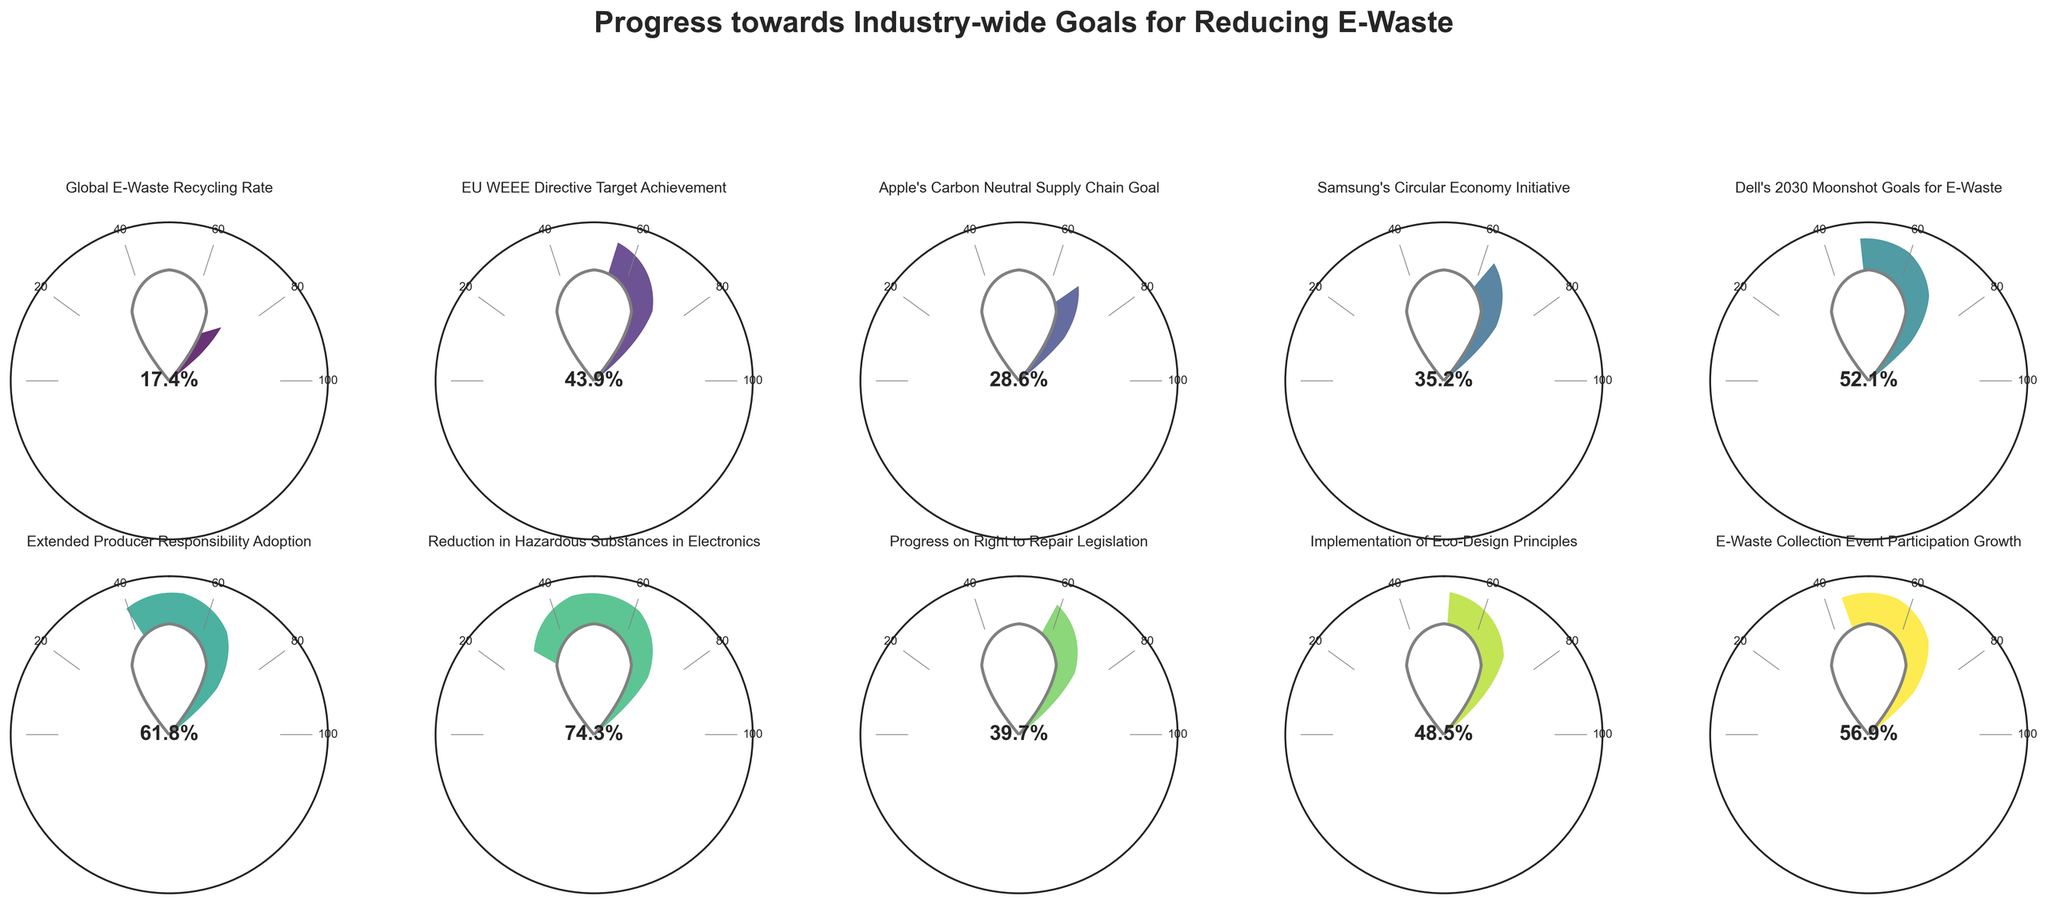Which company has achieved the highest percentage towards their e-waste reduction goals? By observing the gauge charts for each company and comparing the percentages, Dell has the highest percentage of 52.1%.
Answer: Dell How much higher is the EU WEEE Directive Target Achievement compared to Apple's Carbon Neutral Supply Chain Goal? First, identify the percentages for both: EU WEEE Directive is 43.9%, and Apple's Carbon Neutral Supply Chain Goal is 28.6%. Then, subtract Apple's percentage from the EU's: 43.9 - 28.6 = 15.3%.
Answer: 15.3% What is the least advanced category in terms of progress percentage? By examining each gauge chart, the Global E-Waste Recycling Rate has the lowest percentage at 17.4%.
Answer: Global E-Waste Recycling Rate What is the average progress percentage of all the categories combined? Sum all the percentages: 17.4 + 43.9 + 28.6 + 35.2 + 52.1 + 61.8 + 74.3 + 39.7 + 48.5 + 56.9 = 458.4. Divide the total by the number of categories (10): 458.4 / 10 = 45.84%.
Answer: 45.84% Which initiative is closest to the 50% progress mark? Review the gauge charts to find the percentage nearest to 50%. Dell's 2030 Moonshot Goals for E-Waste is 52.1%, and Implementation of Eco-Design Principles is 48.5%. Eco-Design is closer to 50% than Dell.
Answer: Implementation of Eco-Design Principles What is the difference between the highest and lowest progress percentages? Identify the highest (Reduction in Hazardous Substances in Electronics: 74.3%) and lowest (Global E-Waste Recycling Rate: 17.4%). Subtract the lowest from the highest: 74.3 - 17.4 = 56.9%.
Answer: 56.9% How many categories have exceeded the 50% progress mark? Count the categories with percentages above 50%: Dell's 2030 Moonshot Goals for E-Waste (52.1%), Extended Producer Responsibility Adoption (61.8%), Reduction in Hazardous Substances in Electronics (74.3%), and E-Waste Collection Event Participation Growth (56.9%).
Answer: 4 Which category is slightly behind Samsung's Circular Economy Initiative in terms of progress percentage? Identify the percentage of Samsung's Circular Economy Initiative (35.2%) and compare it with other close percentages. Apple's Carbon Neutral Supply Chain Goal is the next closest at 28.6%.
Answer: Apple's Carbon Neutral Supply Chain Goal 